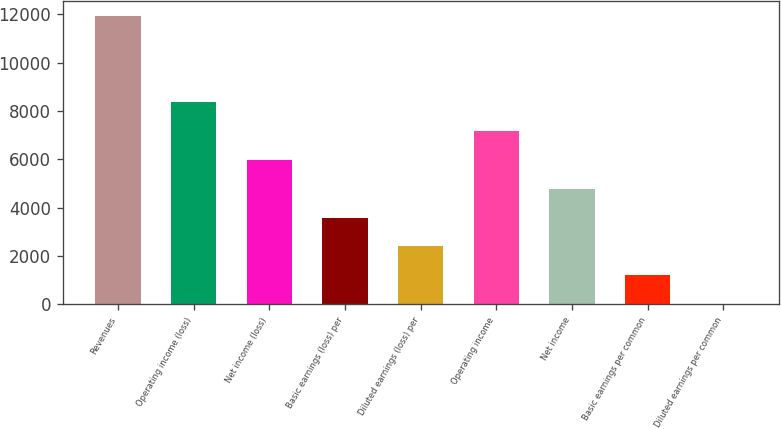Convert chart. <chart><loc_0><loc_0><loc_500><loc_500><bar_chart><fcel>Revenues<fcel>Operating income (loss)<fcel>Net income (loss)<fcel>Basic earnings (loss) per<fcel>Diluted earnings (loss) per<fcel>Operating income<fcel>Net income<fcel>Basic earnings per common<fcel>Diluted earnings per common<nl><fcel>11939<fcel>8357.83<fcel>5970.38<fcel>3582.93<fcel>2389.2<fcel>7164.11<fcel>4776.65<fcel>1195.48<fcel>1.75<nl></chart> 